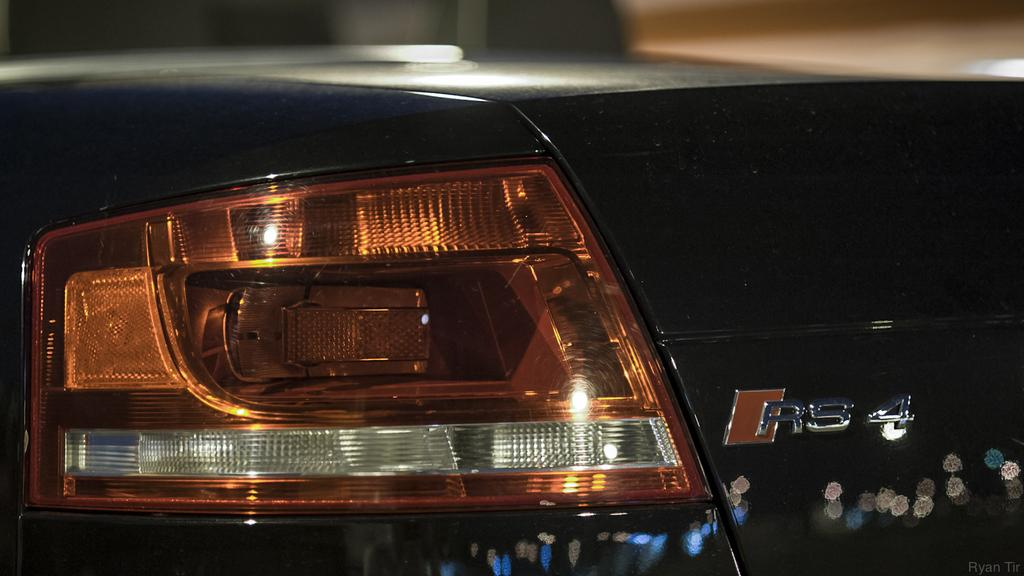What part of the car is the focus of the image? The back part of a car is highlighted in the image. Can you describe the background of the image? The background of the image is blurred. What can be observed on the surface of the car? There is light reflection on the car. What arithmetic problem is being solved on the car's bumper in the image? There is no arithmetic problem visible on the car's bumper in the image. What type of test is being conducted on the car in the image? There is no test being conducted on the car in the image; it is simply a stationary car with a highlighted back part. 